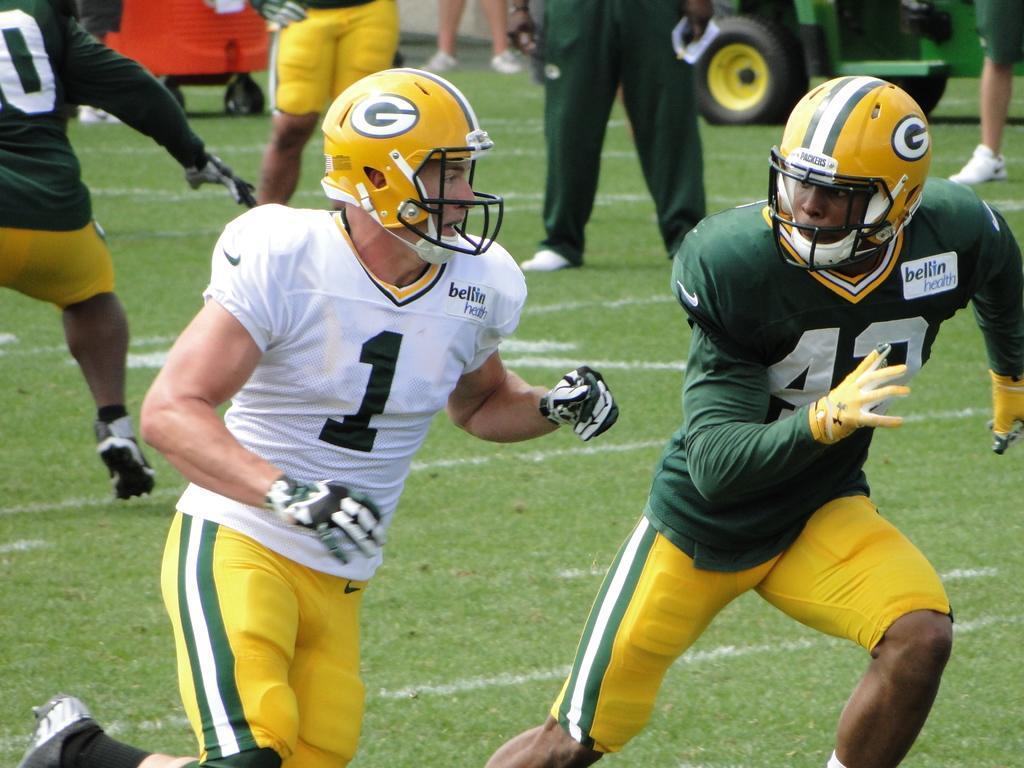Can you describe this image briefly? In the foreground of this image, there are two men wearing T shirts, shorts, helmets and gloves are running on the grass. In the background, there are people and two vehicles like objects. 